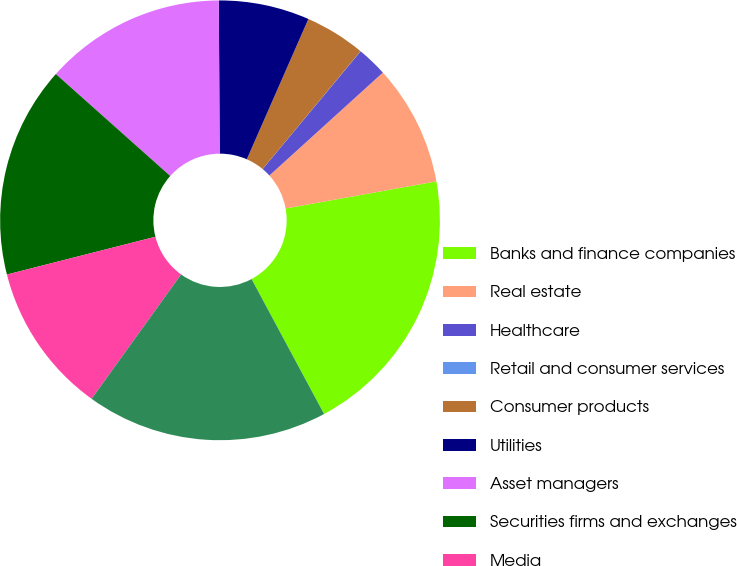Convert chart. <chart><loc_0><loc_0><loc_500><loc_500><pie_chart><fcel>Banks and finance companies<fcel>Real estate<fcel>Healthcare<fcel>Retail and consumer services<fcel>Consumer products<fcel>Utilities<fcel>Asset managers<fcel>Securities firms and exchanges<fcel>Media<fcel>All other<nl><fcel>19.99%<fcel>8.89%<fcel>2.23%<fcel>0.01%<fcel>4.45%<fcel>6.67%<fcel>13.33%<fcel>15.55%<fcel>11.11%<fcel>17.77%<nl></chart> 